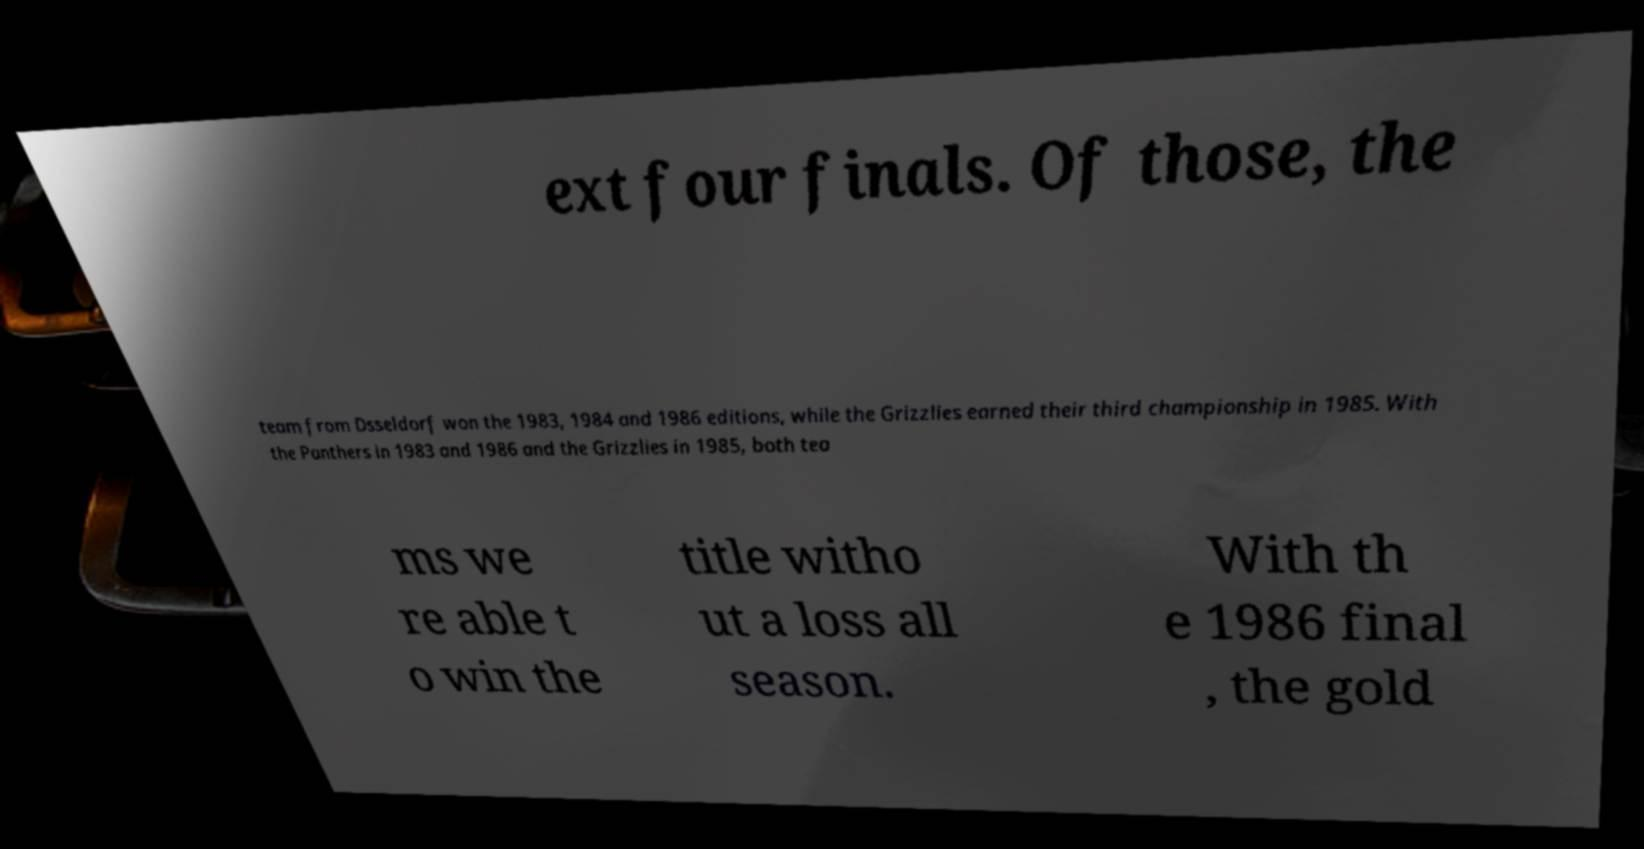For documentation purposes, I need the text within this image transcribed. Could you provide that? ext four finals. Of those, the team from Dsseldorf won the 1983, 1984 and 1986 editions, while the Grizzlies earned their third championship in 1985. With the Panthers in 1983 and 1986 and the Grizzlies in 1985, both tea ms we re able t o win the title witho ut a loss all season. With th e 1986 final , the gold 